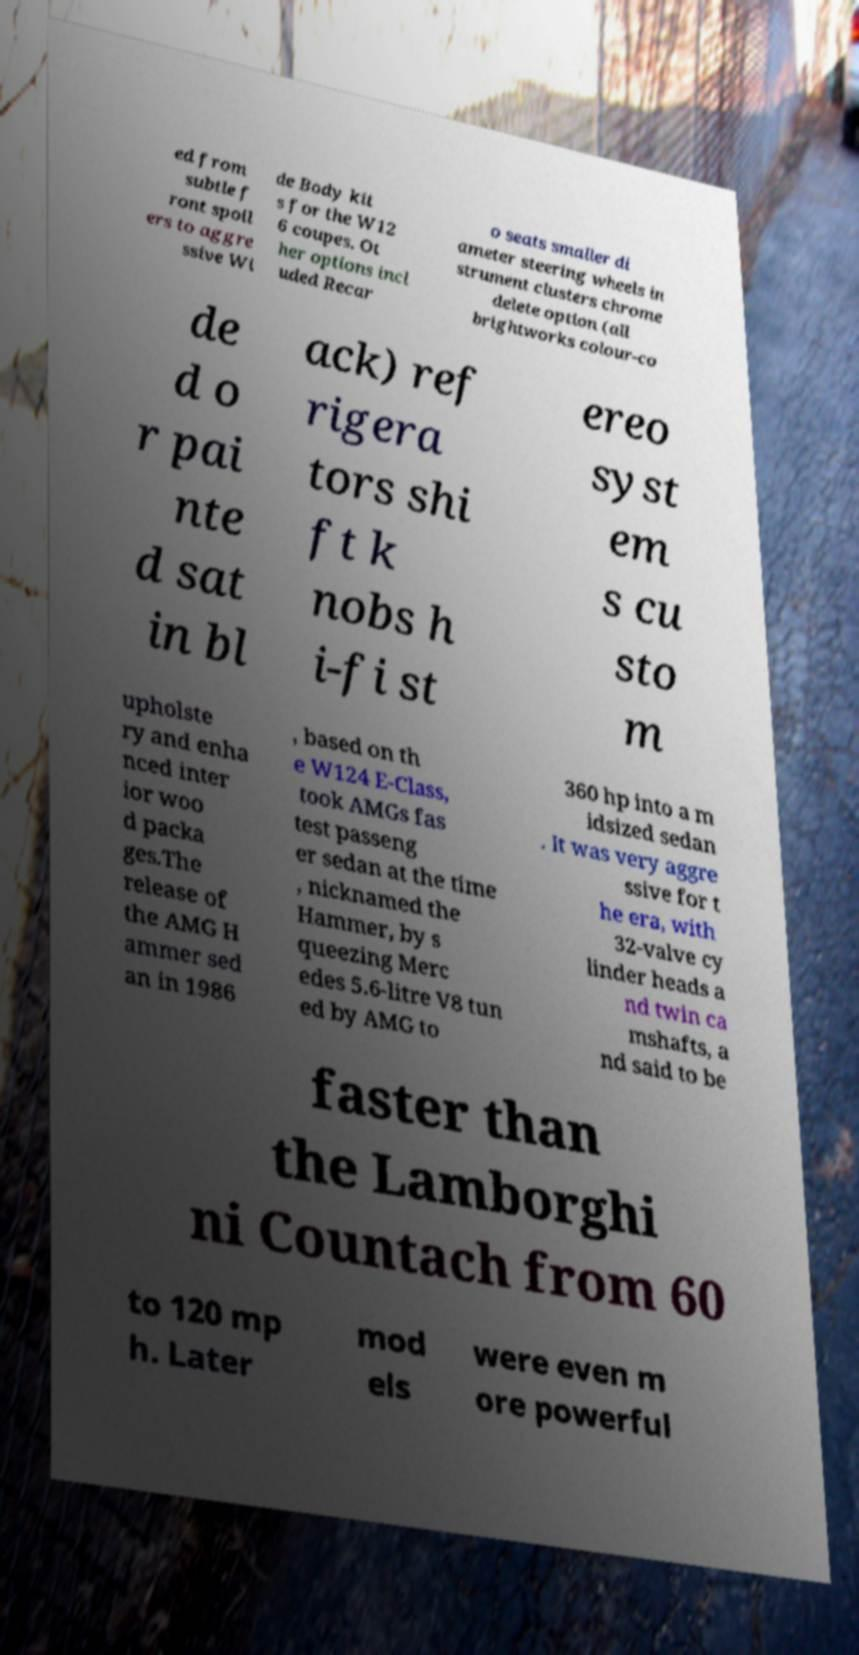Can you accurately transcribe the text from the provided image for me? ed from subtle f ront spoil ers to aggre ssive Wi de Body kit s for the W12 6 coupes. Ot her options incl uded Recar o seats smaller di ameter steering wheels in strument clusters chrome delete option (all brightworks colour-co de d o r pai nte d sat in bl ack) ref rigera tors shi ft k nobs h i-fi st ereo syst em s cu sto m upholste ry and enha nced inter ior woo d packa ges.The release of the AMG H ammer sed an in 1986 , based on th e W124 E-Class, took AMGs fas test passeng er sedan at the time , nicknamed the Hammer, by s queezing Merc edes 5.6-litre V8 tun ed by AMG to 360 hp into a m idsized sedan . It was very aggre ssive for t he era, with 32-valve cy linder heads a nd twin ca mshafts, a nd said to be faster than the Lamborghi ni Countach from 60 to 120 mp h. Later mod els were even m ore powerful 